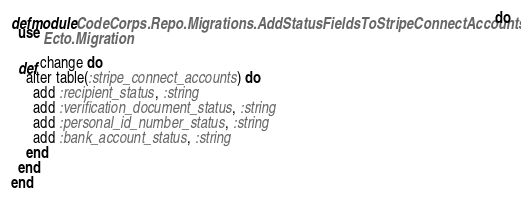<code> <loc_0><loc_0><loc_500><loc_500><_Elixir_>defmodule CodeCorps.Repo.Migrations.AddStatusFieldsToStripeConnectAccounts do
  use Ecto.Migration

  def change do
    alter table(:stripe_connect_accounts) do
      add :recipient_status, :string
      add :verification_document_status, :string
      add :personal_id_number_status, :string
      add :bank_account_status, :string
    end
  end
end
</code> 